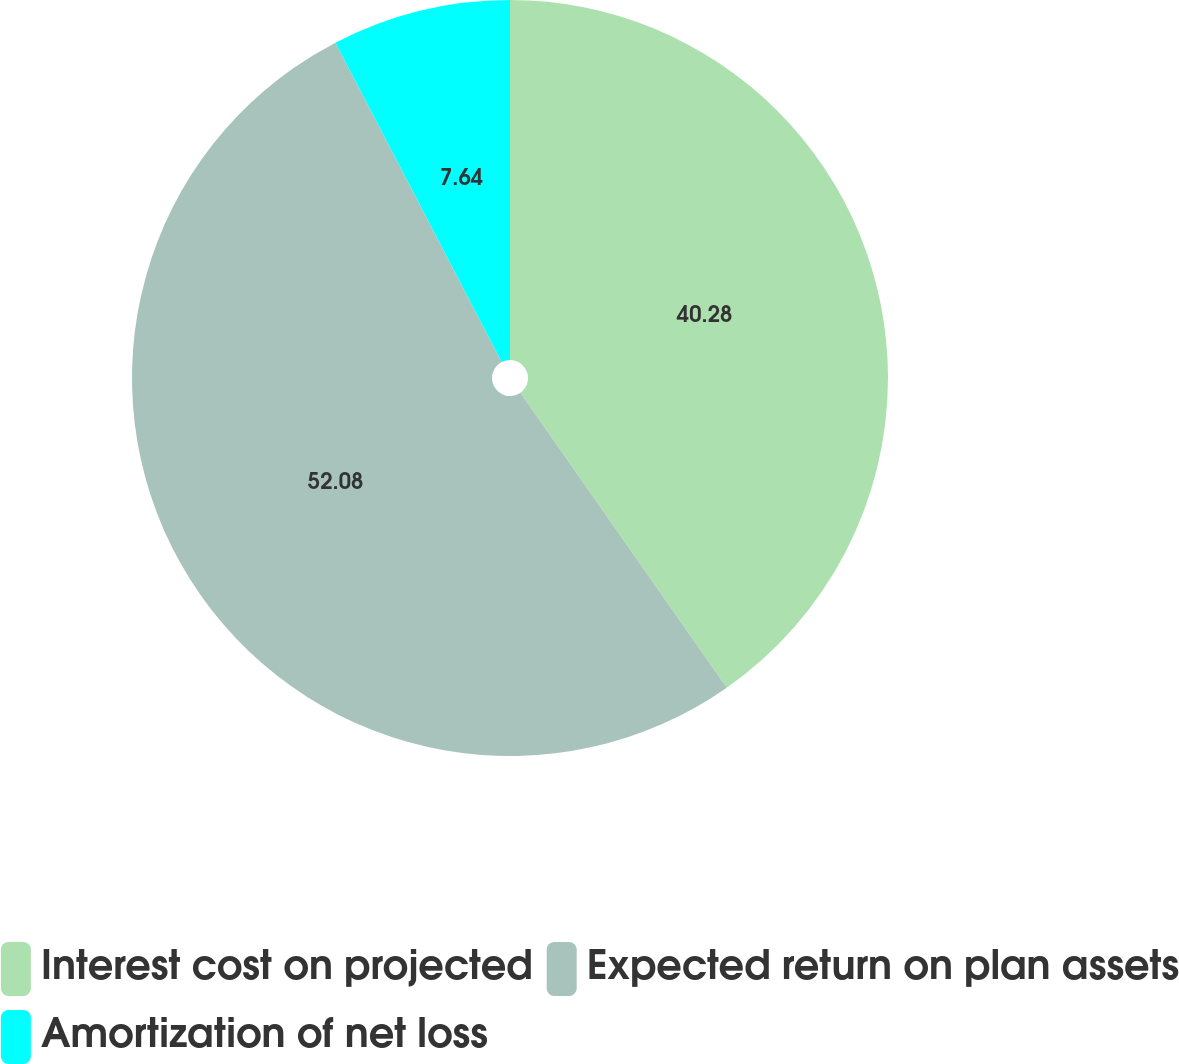<chart> <loc_0><loc_0><loc_500><loc_500><pie_chart><fcel>Interest cost on projected<fcel>Expected return on plan assets<fcel>Amortization of net loss<nl><fcel>40.28%<fcel>52.08%<fcel>7.64%<nl></chart> 